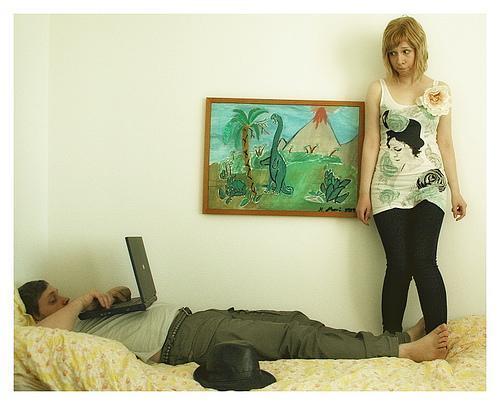How many people can you see?
Give a very brief answer. 2. 